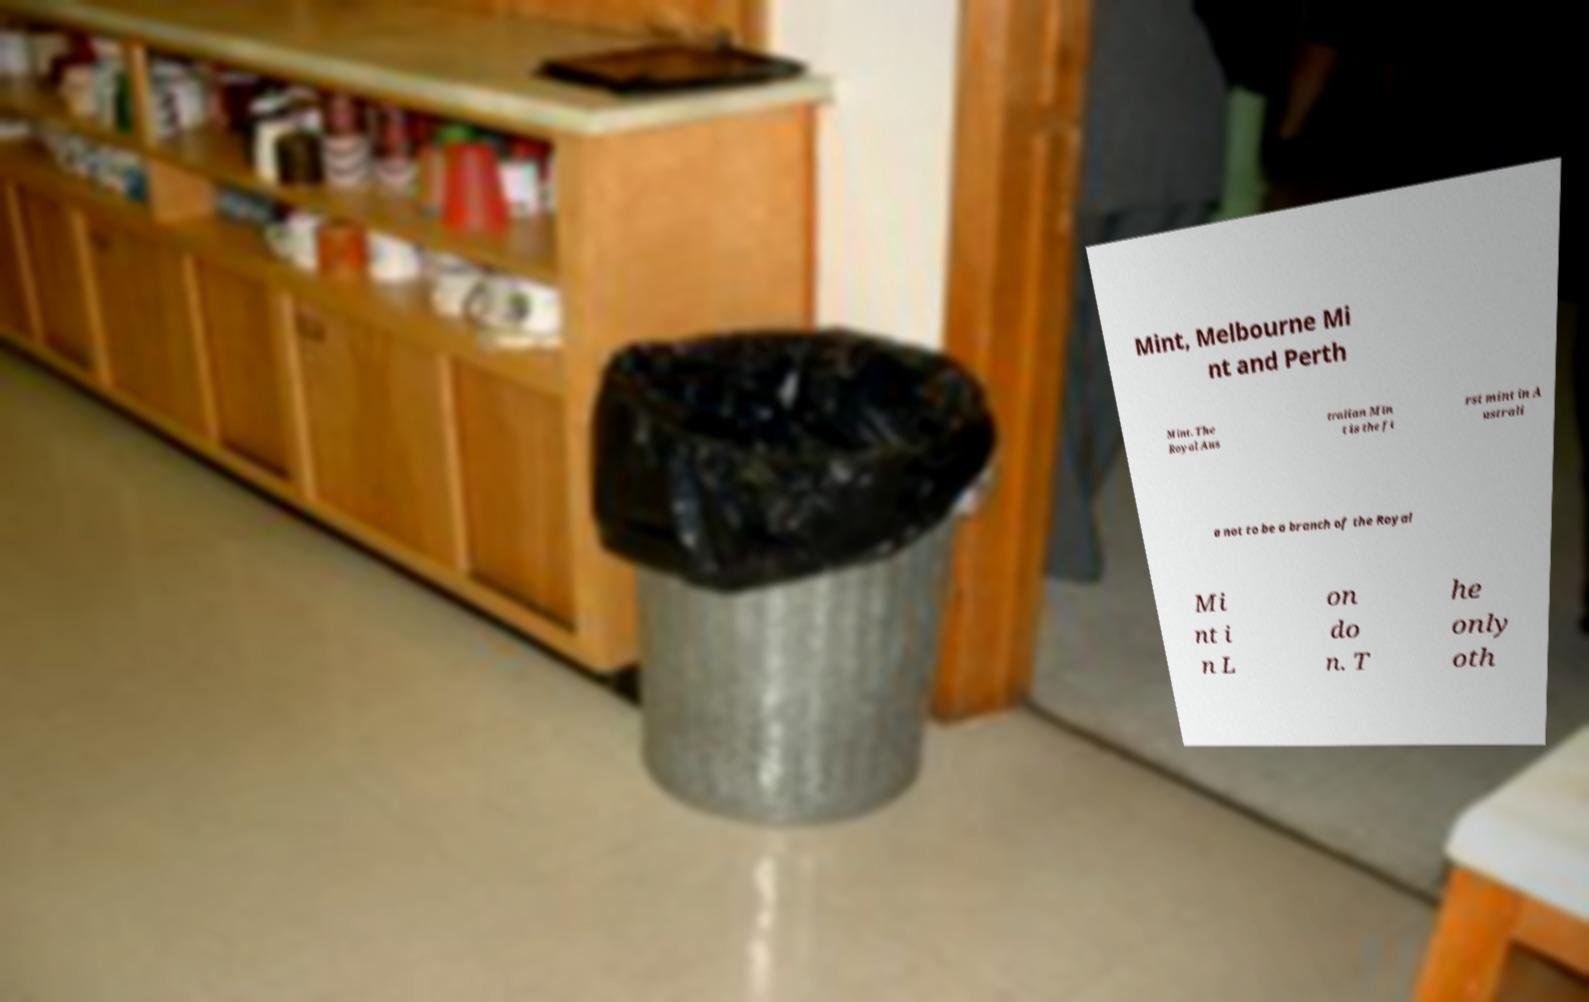I need the written content from this picture converted into text. Can you do that? Mint, Melbourne Mi nt and Perth Mint. The Royal Aus tralian Min t is the fi rst mint in A ustrali a not to be a branch of the Royal Mi nt i n L on do n. T he only oth 